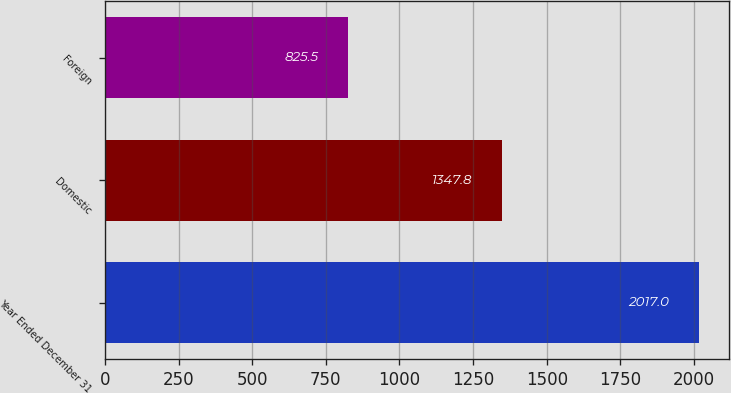<chart> <loc_0><loc_0><loc_500><loc_500><bar_chart><fcel>Year Ended December 31<fcel>Domestic<fcel>Foreign<nl><fcel>2017<fcel>1347.8<fcel>825.5<nl></chart> 